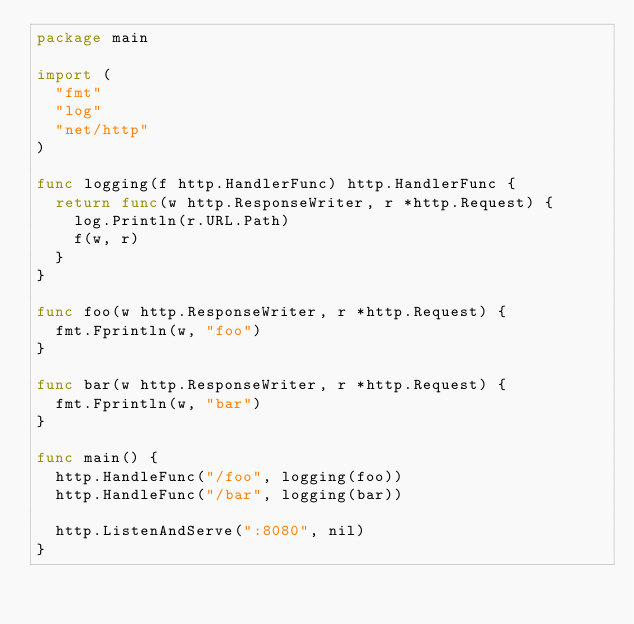Convert code to text. <code><loc_0><loc_0><loc_500><loc_500><_Go_>package main

import (
	"fmt"
	"log"
	"net/http"
)

func logging(f http.HandlerFunc) http.HandlerFunc {
	return func(w http.ResponseWriter, r *http.Request) {
		log.Println(r.URL.Path)
		f(w, r)
	}
}

func foo(w http.ResponseWriter, r *http.Request) {
	fmt.Fprintln(w, "foo")
}

func bar(w http.ResponseWriter, r *http.Request) {
	fmt.Fprintln(w, "bar")
}

func main() {
	http.HandleFunc("/foo", logging(foo))
	http.HandleFunc("/bar", logging(bar))

	http.ListenAndServe(":8080", nil)
}
</code> 